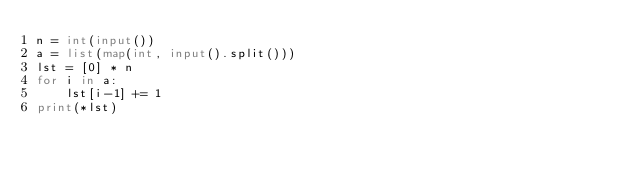<code> <loc_0><loc_0><loc_500><loc_500><_Python_>n = int(input())
a = list(map(int, input().split()))
lst = [0] * n
for i in a:
    lst[i-1] += 1
print(*lst)</code> 